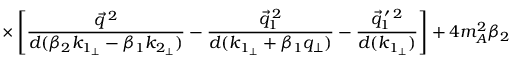Convert formula to latex. <formula><loc_0><loc_0><loc_500><loc_500>\times \left [ \frac { \vec { q } ^ { \, 2 } } { d ( \beta _ { 2 } k _ { 1 _ { \perp } } - \beta _ { 1 } k _ { 2 _ { \perp } } ) } - \frac { \vec { q } _ { 1 } ^ { \, 2 } } { d ( k _ { 1 _ { \perp } } + \beta _ { 1 } q _ { \perp } ) } - \frac { \vec { q } _ { 1 } ^ { \, \prime \, 2 } } { d ( k _ { 1 _ { \perp } } ) } \right ] + 4 m _ { A } ^ { 2 } \beta _ { 2 }</formula> 